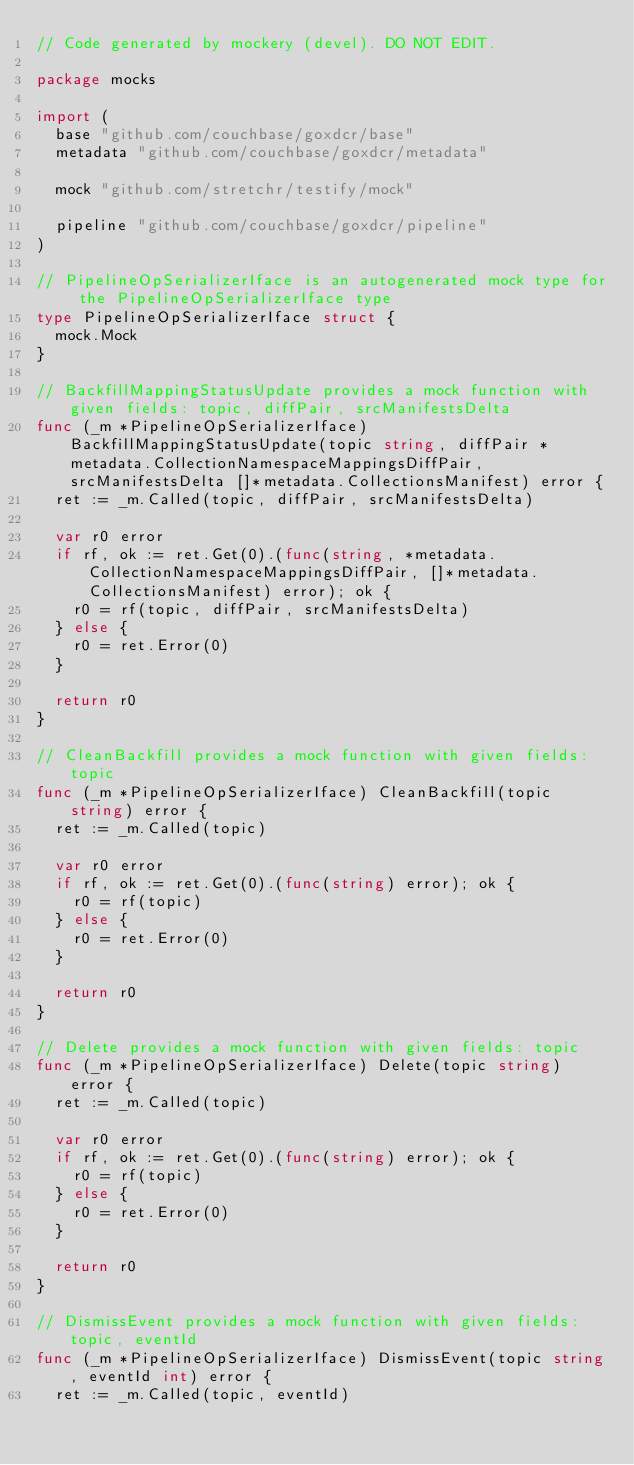Convert code to text. <code><loc_0><loc_0><loc_500><loc_500><_Go_>// Code generated by mockery (devel). DO NOT EDIT.

package mocks

import (
	base "github.com/couchbase/goxdcr/base"
	metadata "github.com/couchbase/goxdcr/metadata"

	mock "github.com/stretchr/testify/mock"

	pipeline "github.com/couchbase/goxdcr/pipeline"
)

// PipelineOpSerializerIface is an autogenerated mock type for the PipelineOpSerializerIface type
type PipelineOpSerializerIface struct {
	mock.Mock
}

// BackfillMappingStatusUpdate provides a mock function with given fields: topic, diffPair, srcManifestsDelta
func (_m *PipelineOpSerializerIface) BackfillMappingStatusUpdate(topic string, diffPair *metadata.CollectionNamespaceMappingsDiffPair, srcManifestsDelta []*metadata.CollectionsManifest) error {
	ret := _m.Called(topic, diffPair, srcManifestsDelta)

	var r0 error
	if rf, ok := ret.Get(0).(func(string, *metadata.CollectionNamespaceMappingsDiffPair, []*metadata.CollectionsManifest) error); ok {
		r0 = rf(topic, diffPair, srcManifestsDelta)
	} else {
		r0 = ret.Error(0)
	}

	return r0
}

// CleanBackfill provides a mock function with given fields: topic
func (_m *PipelineOpSerializerIface) CleanBackfill(topic string) error {
	ret := _m.Called(topic)

	var r0 error
	if rf, ok := ret.Get(0).(func(string) error); ok {
		r0 = rf(topic)
	} else {
		r0 = ret.Error(0)
	}

	return r0
}

// Delete provides a mock function with given fields: topic
func (_m *PipelineOpSerializerIface) Delete(topic string) error {
	ret := _m.Called(topic)

	var r0 error
	if rf, ok := ret.Get(0).(func(string) error); ok {
		r0 = rf(topic)
	} else {
		r0 = ret.Error(0)
	}

	return r0
}

// DismissEvent provides a mock function with given fields: topic, eventId
func (_m *PipelineOpSerializerIface) DismissEvent(topic string, eventId int) error {
	ret := _m.Called(topic, eventId)
</code> 